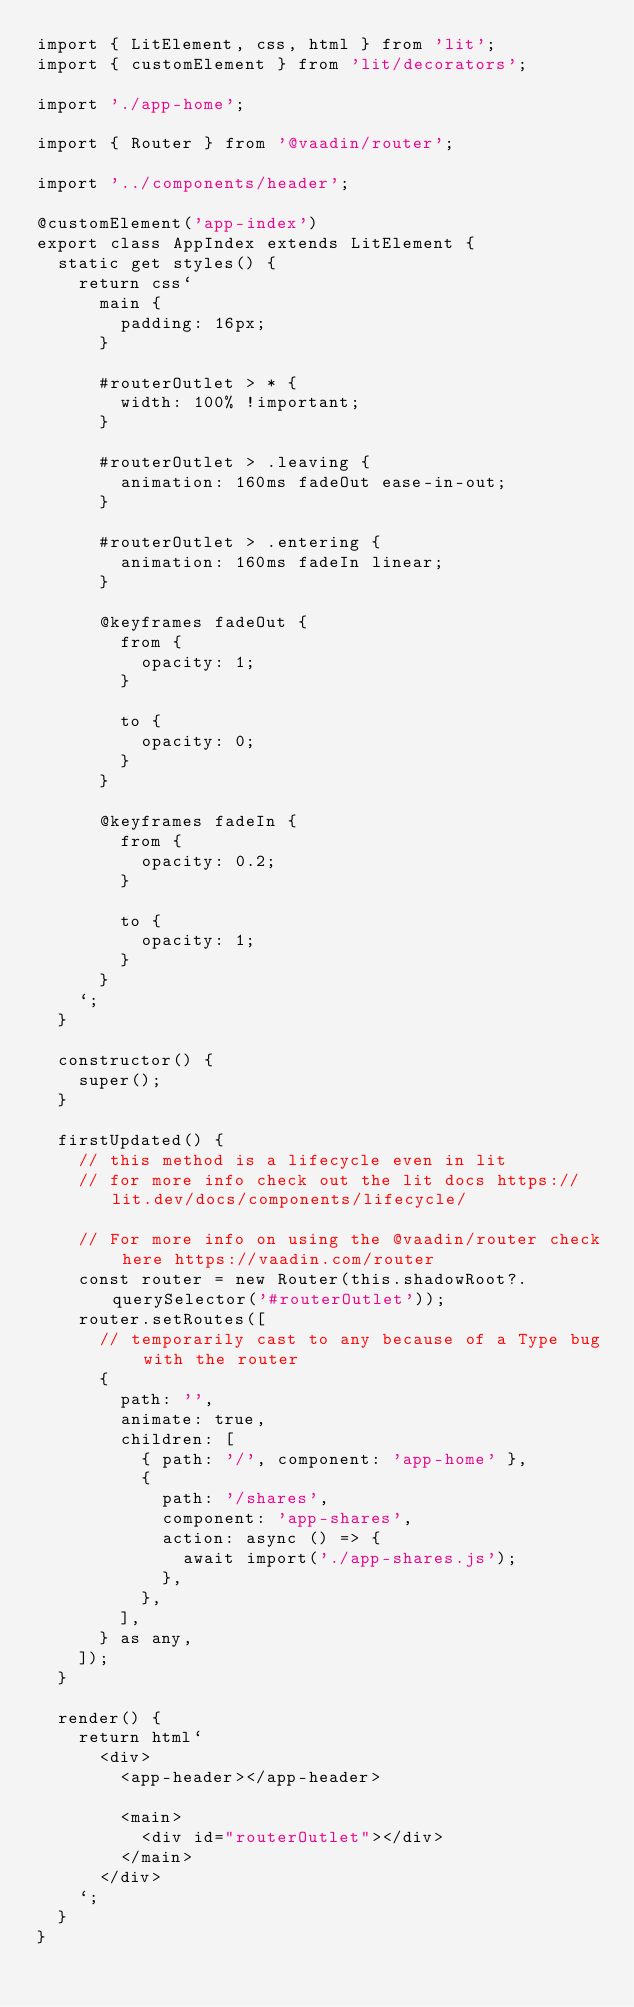<code> <loc_0><loc_0><loc_500><loc_500><_TypeScript_>import { LitElement, css, html } from 'lit';
import { customElement } from 'lit/decorators';

import './app-home';

import { Router } from '@vaadin/router';

import '../components/header';

@customElement('app-index')
export class AppIndex extends LitElement {
  static get styles() {
    return css`
      main {
        padding: 16px;
      }

      #routerOutlet > * {
        width: 100% !important;
      }

      #routerOutlet > .leaving {
        animation: 160ms fadeOut ease-in-out;
      }

      #routerOutlet > .entering {
        animation: 160ms fadeIn linear;
      }

      @keyframes fadeOut {
        from {
          opacity: 1;
        }

        to {
          opacity: 0;
        }
      }

      @keyframes fadeIn {
        from {
          opacity: 0.2;
        }

        to {
          opacity: 1;
        }
      }
    `;
  }

  constructor() {
    super();
  }

  firstUpdated() {
    // this method is a lifecycle even in lit
    // for more info check out the lit docs https://lit.dev/docs/components/lifecycle/

    // For more info on using the @vaadin/router check here https://vaadin.com/router
    const router = new Router(this.shadowRoot?.querySelector('#routerOutlet'));
    router.setRoutes([
      // temporarily cast to any because of a Type bug with the router
      {
        path: '',
        animate: true,
        children: [
          { path: '/', component: 'app-home' },
          {
            path: '/shares',
            component: 'app-shares',
            action: async () => {
              await import('./app-shares.js');
            },
          },
        ],
      } as any,
    ]);
  }

  render() {
    return html`
      <div>
        <app-header></app-header>

        <main>
          <div id="routerOutlet"></div>
        </main>
      </div>
    `;
  }
}
</code> 